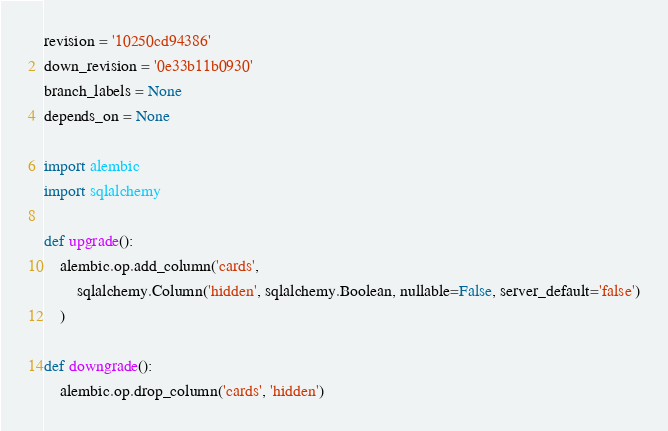Convert code to text. <code><loc_0><loc_0><loc_500><loc_500><_Python_>revision = '10250cd94386'
down_revision = '0e33b11b0930'
branch_labels = None
depends_on = None

import alembic
import sqlalchemy

def upgrade():
	alembic.op.add_column('cards',
		sqlalchemy.Column('hidden', sqlalchemy.Boolean, nullable=False, server_default='false')
	)

def downgrade():
	alembic.op.drop_column('cards', 'hidden')
</code> 